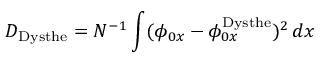<formula> <loc_0><loc_0><loc_500><loc_500>D _ { D y s t h e } = N ^ { - 1 } \int ( \phi _ { 0 x } - \phi _ { 0 x } ^ { D y s t h e } ) ^ { 2 } \, d x</formula> 